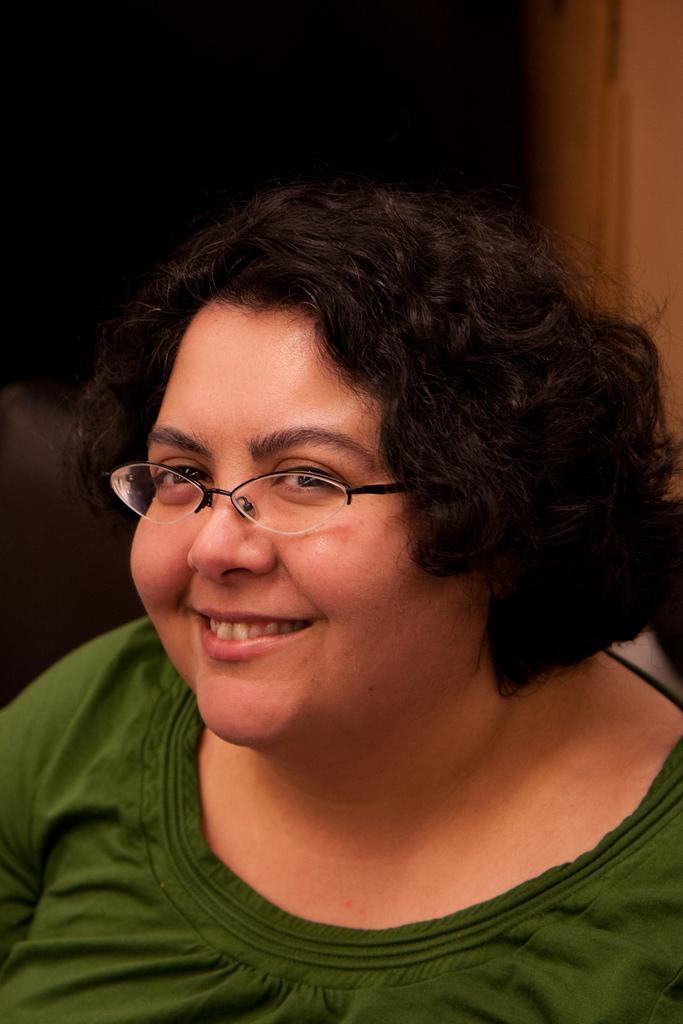Describe this image in one or two sentences. In this image in the foreground there is a woman wearing a spectacle, she is smiling. 